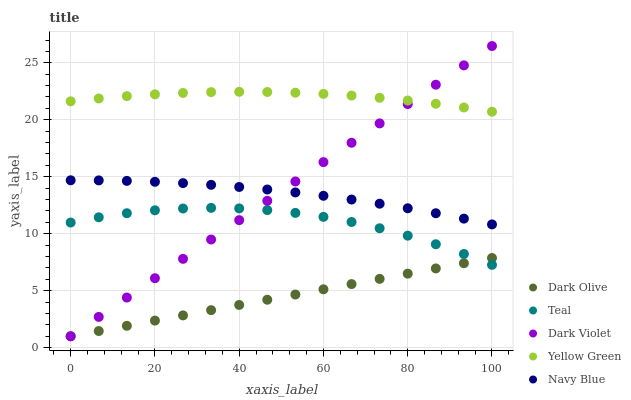Does Dark Olive have the minimum area under the curve?
Answer yes or no. Yes. Does Yellow Green have the maximum area under the curve?
Answer yes or no. Yes. Does Dark Violet have the minimum area under the curve?
Answer yes or no. No. Does Dark Violet have the maximum area under the curve?
Answer yes or no. No. Is Dark Olive the smoothest?
Answer yes or no. Yes. Is Teal the roughest?
Answer yes or no. Yes. Is Dark Violet the smoothest?
Answer yes or no. No. Is Dark Violet the roughest?
Answer yes or no. No. Does Dark Olive have the lowest value?
Answer yes or no. Yes. Does Teal have the lowest value?
Answer yes or no. No. Does Dark Violet have the highest value?
Answer yes or no. Yes. Does Dark Olive have the highest value?
Answer yes or no. No. Is Teal less than Navy Blue?
Answer yes or no. Yes. Is Yellow Green greater than Teal?
Answer yes or no. Yes. Does Dark Violet intersect Navy Blue?
Answer yes or no. Yes. Is Dark Violet less than Navy Blue?
Answer yes or no. No. Is Dark Violet greater than Navy Blue?
Answer yes or no. No. Does Teal intersect Navy Blue?
Answer yes or no. No. 